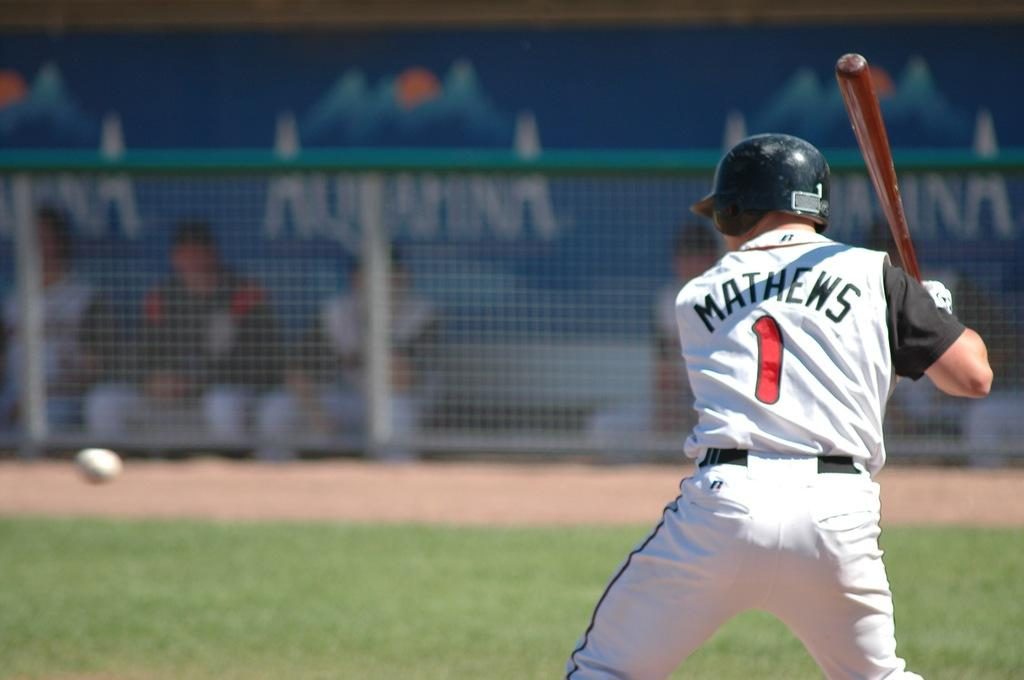<image>
Describe the image concisely. A baseball player is batting with a jersey on with the number one on the back. 